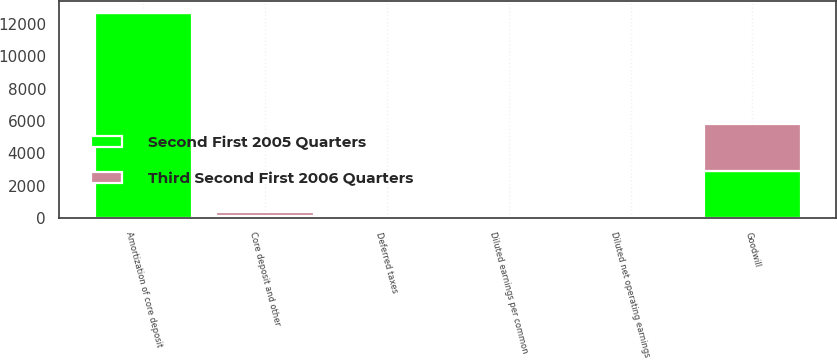Convert chart. <chart><loc_0><loc_0><loc_500><loc_500><stacked_bar_chart><ecel><fcel>Amortization of core deposit<fcel>Diluted earnings per common<fcel>Diluted net operating earnings<fcel>Goodwill<fcel>Core deposit and other<fcel>Deferred taxes<nl><fcel>Third Second First 2006 Quarters<fcel>115<fcel>1.88<fcel>1.98<fcel>2909<fcel>261<fcel>32<nl><fcel>Second First 2005 Quarters<fcel>12703<fcel>1.78<fcel>1.85<fcel>2904<fcel>115<fcel>44<nl></chart> 